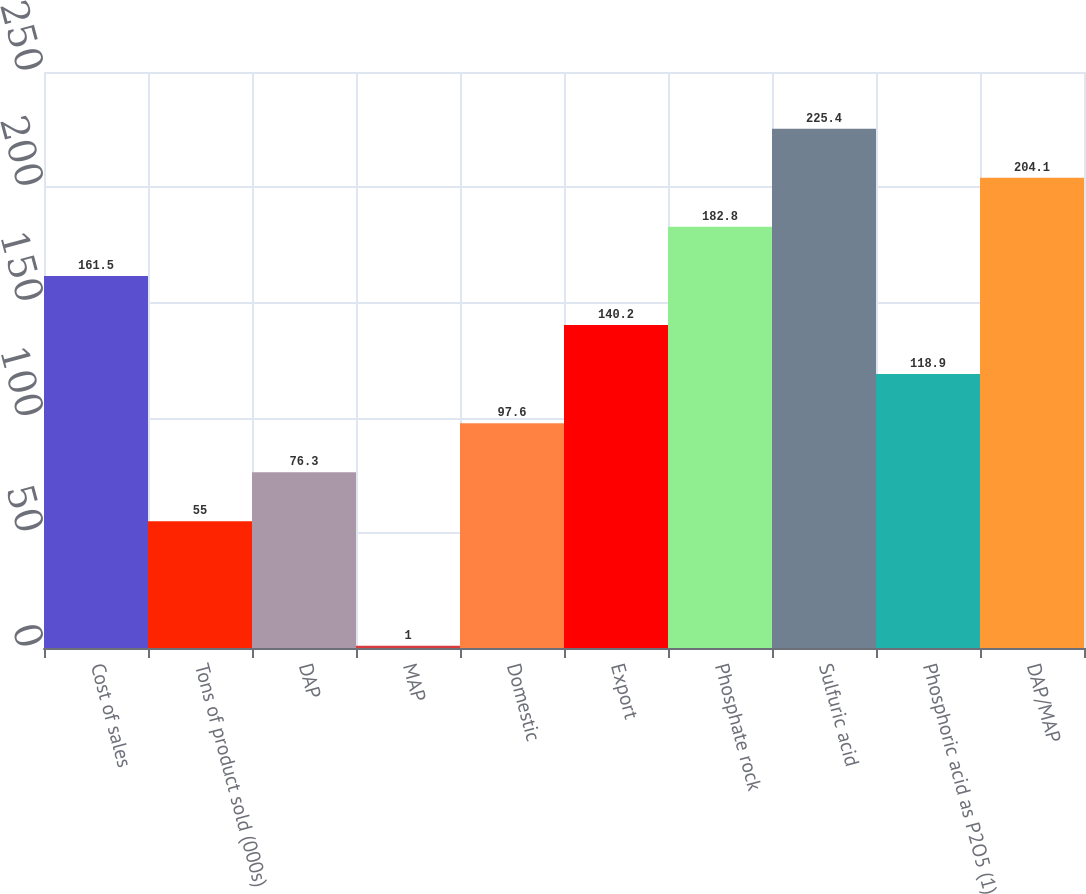Convert chart to OTSL. <chart><loc_0><loc_0><loc_500><loc_500><bar_chart><fcel>Cost of sales<fcel>Tons of product sold (000s)<fcel>DAP<fcel>MAP<fcel>Domestic<fcel>Export<fcel>Phosphate rock<fcel>Sulfuric acid<fcel>Phosphoric acid as P2O5 (1)<fcel>DAP/MAP<nl><fcel>161.5<fcel>55<fcel>76.3<fcel>1<fcel>97.6<fcel>140.2<fcel>182.8<fcel>225.4<fcel>118.9<fcel>204.1<nl></chart> 